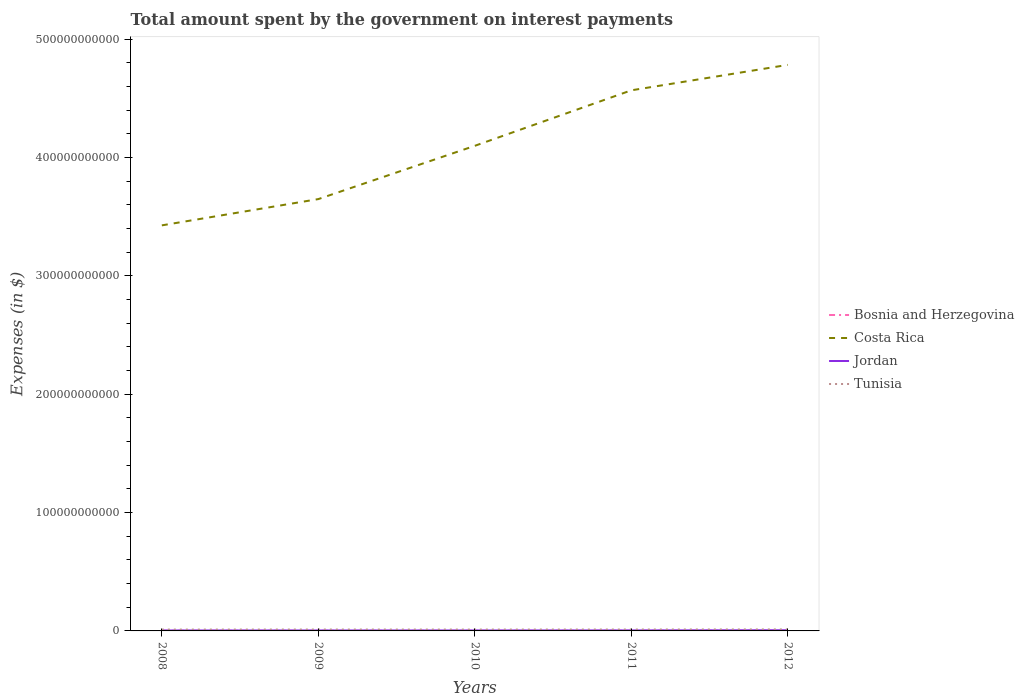How many different coloured lines are there?
Your answer should be very brief. 4. Across all years, what is the maximum amount spent on interest payments by the government in Jordan?
Your answer should be compact. 3.78e+08. What is the total amount spent on interest payments by the government in Jordan in the graph?
Keep it short and to the point. -5.17e+07. What is the difference between the highest and the second highest amount spent on interest payments by the government in Bosnia and Herzegovina?
Your answer should be compact. 7.29e+07. What is the difference between the highest and the lowest amount spent on interest payments by the government in Bosnia and Herzegovina?
Provide a short and direct response. 2. Is the amount spent on interest payments by the government in Jordan strictly greater than the amount spent on interest payments by the government in Tunisia over the years?
Your answer should be very brief. Yes. What is the difference between two consecutive major ticks on the Y-axis?
Keep it short and to the point. 1.00e+11. Where does the legend appear in the graph?
Provide a succinct answer. Center right. What is the title of the graph?
Your answer should be very brief. Total amount spent by the government on interest payments. Does "Kosovo" appear as one of the legend labels in the graph?
Provide a short and direct response. No. What is the label or title of the Y-axis?
Provide a succinct answer. Expenses (in $). What is the Expenses (in $) in Bosnia and Herzegovina in 2008?
Give a very brief answer. 1.15e+08. What is the Expenses (in $) in Costa Rica in 2008?
Ensure brevity in your answer.  3.43e+11. What is the Expenses (in $) in Jordan in 2008?
Offer a very short reply. 3.78e+08. What is the Expenses (in $) in Tunisia in 2008?
Offer a very short reply. 1.14e+09. What is the Expenses (in $) of Bosnia and Herzegovina in 2009?
Your answer should be compact. 1.13e+08. What is the Expenses (in $) in Costa Rica in 2009?
Offer a terse response. 3.65e+11. What is the Expenses (in $) of Jordan in 2009?
Offer a terse response. 3.92e+08. What is the Expenses (in $) of Tunisia in 2009?
Make the answer very short. 1.18e+09. What is the Expenses (in $) in Bosnia and Herzegovina in 2010?
Provide a succinct answer. 1.08e+08. What is the Expenses (in $) in Costa Rica in 2010?
Your answer should be compact. 4.10e+11. What is the Expenses (in $) of Jordan in 2010?
Your answer should be very brief. 3.98e+08. What is the Expenses (in $) of Tunisia in 2010?
Offer a very short reply. 1.15e+09. What is the Expenses (in $) of Bosnia and Herzegovina in 2011?
Make the answer very short. 1.44e+08. What is the Expenses (in $) in Costa Rica in 2011?
Make the answer very short. 4.57e+11. What is the Expenses (in $) of Jordan in 2011?
Provide a succinct answer. 4.30e+08. What is the Expenses (in $) of Tunisia in 2011?
Offer a very short reply. 1.19e+09. What is the Expenses (in $) of Bosnia and Herzegovina in 2012?
Offer a terse response. 1.81e+08. What is the Expenses (in $) of Costa Rica in 2012?
Give a very brief answer. 4.78e+11. What is the Expenses (in $) of Jordan in 2012?
Your answer should be compact. 5.83e+08. What is the Expenses (in $) in Tunisia in 2012?
Give a very brief answer. 1.27e+09. Across all years, what is the maximum Expenses (in $) of Bosnia and Herzegovina?
Your answer should be compact. 1.81e+08. Across all years, what is the maximum Expenses (in $) of Costa Rica?
Your answer should be very brief. 4.78e+11. Across all years, what is the maximum Expenses (in $) in Jordan?
Offer a very short reply. 5.83e+08. Across all years, what is the maximum Expenses (in $) of Tunisia?
Your answer should be compact. 1.27e+09. Across all years, what is the minimum Expenses (in $) of Bosnia and Herzegovina?
Make the answer very short. 1.08e+08. Across all years, what is the minimum Expenses (in $) of Costa Rica?
Keep it short and to the point. 3.43e+11. Across all years, what is the minimum Expenses (in $) of Jordan?
Keep it short and to the point. 3.78e+08. Across all years, what is the minimum Expenses (in $) in Tunisia?
Offer a very short reply. 1.14e+09. What is the total Expenses (in $) of Bosnia and Herzegovina in the graph?
Offer a very short reply. 6.60e+08. What is the total Expenses (in $) of Costa Rica in the graph?
Give a very brief answer. 2.05e+12. What is the total Expenses (in $) of Jordan in the graph?
Your response must be concise. 2.18e+09. What is the total Expenses (in $) of Tunisia in the graph?
Keep it short and to the point. 5.94e+09. What is the difference between the Expenses (in $) in Bosnia and Herzegovina in 2008 and that in 2009?
Give a very brief answer. 1.95e+06. What is the difference between the Expenses (in $) in Costa Rica in 2008 and that in 2009?
Give a very brief answer. -2.22e+1. What is the difference between the Expenses (in $) of Jordan in 2008 and that in 2009?
Your response must be concise. -1.44e+07. What is the difference between the Expenses (in $) of Tunisia in 2008 and that in 2009?
Offer a terse response. -3.76e+07. What is the difference between the Expenses (in $) of Bosnia and Herzegovina in 2008 and that in 2010?
Provide a short and direct response. 6.36e+06. What is the difference between the Expenses (in $) of Costa Rica in 2008 and that in 2010?
Your answer should be very brief. -6.72e+1. What is the difference between the Expenses (in $) in Jordan in 2008 and that in 2010?
Ensure brevity in your answer.  -1.97e+07. What is the difference between the Expenses (in $) of Tunisia in 2008 and that in 2010?
Your answer should be very brief. -9.50e+06. What is the difference between the Expenses (in $) in Bosnia and Herzegovina in 2008 and that in 2011?
Provide a succinct answer. -2.93e+07. What is the difference between the Expenses (in $) of Costa Rica in 2008 and that in 2011?
Make the answer very short. -1.14e+11. What is the difference between the Expenses (in $) of Jordan in 2008 and that in 2011?
Offer a very short reply. -5.17e+07. What is the difference between the Expenses (in $) of Tunisia in 2008 and that in 2011?
Keep it short and to the point. -4.76e+07. What is the difference between the Expenses (in $) in Bosnia and Herzegovina in 2008 and that in 2012?
Keep it short and to the point. -6.65e+07. What is the difference between the Expenses (in $) of Costa Rica in 2008 and that in 2012?
Offer a terse response. -1.36e+11. What is the difference between the Expenses (in $) of Jordan in 2008 and that in 2012?
Your answer should be compact. -2.05e+08. What is the difference between the Expenses (in $) of Tunisia in 2008 and that in 2012?
Give a very brief answer. -1.30e+08. What is the difference between the Expenses (in $) in Bosnia and Herzegovina in 2009 and that in 2010?
Provide a short and direct response. 4.41e+06. What is the difference between the Expenses (in $) of Costa Rica in 2009 and that in 2010?
Give a very brief answer. -4.50e+1. What is the difference between the Expenses (in $) in Jordan in 2009 and that in 2010?
Make the answer very short. -5.30e+06. What is the difference between the Expenses (in $) of Tunisia in 2009 and that in 2010?
Make the answer very short. 2.81e+07. What is the difference between the Expenses (in $) of Bosnia and Herzegovina in 2009 and that in 2011?
Offer a terse response. -3.12e+07. What is the difference between the Expenses (in $) in Costa Rica in 2009 and that in 2011?
Provide a succinct answer. -9.19e+1. What is the difference between the Expenses (in $) of Jordan in 2009 and that in 2011?
Give a very brief answer. -3.73e+07. What is the difference between the Expenses (in $) in Tunisia in 2009 and that in 2011?
Provide a succinct answer. -1.00e+07. What is the difference between the Expenses (in $) in Bosnia and Herzegovina in 2009 and that in 2012?
Give a very brief answer. -6.85e+07. What is the difference between the Expenses (in $) in Costa Rica in 2009 and that in 2012?
Offer a terse response. -1.13e+11. What is the difference between the Expenses (in $) in Jordan in 2009 and that in 2012?
Keep it short and to the point. -1.91e+08. What is the difference between the Expenses (in $) of Tunisia in 2009 and that in 2012?
Your answer should be compact. -9.20e+07. What is the difference between the Expenses (in $) of Bosnia and Herzegovina in 2010 and that in 2011?
Your answer should be compact. -3.56e+07. What is the difference between the Expenses (in $) in Costa Rica in 2010 and that in 2011?
Give a very brief answer. -4.69e+1. What is the difference between the Expenses (in $) of Jordan in 2010 and that in 2011?
Your response must be concise. -3.20e+07. What is the difference between the Expenses (in $) of Tunisia in 2010 and that in 2011?
Your answer should be very brief. -3.81e+07. What is the difference between the Expenses (in $) of Bosnia and Herzegovina in 2010 and that in 2012?
Provide a succinct answer. -7.29e+07. What is the difference between the Expenses (in $) of Costa Rica in 2010 and that in 2012?
Offer a terse response. -6.84e+1. What is the difference between the Expenses (in $) of Jordan in 2010 and that in 2012?
Offer a very short reply. -1.86e+08. What is the difference between the Expenses (in $) of Tunisia in 2010 and that in 2012?
Give a very brief answer. -1.20e+08. What is the difference between the Expenses (in $) in Bosnia and Herzegovina in 2011 and that in 2012?
Offer a terse response. -3.73e+07. What is the difference between the Expenses (in $) of Costa Rica in 2011 and that in 2012?
Make the answer very short. -2.15e+1. What is the difference between the Expenses (in $) of Jordan in 2011 and that in 2012?
Offer a very short reply. -1.54e+08. What is the difference between the Expenses (in $) in Tunisia in 2011 and that in 2012?
Offer a very short reply. -8.20e+07. What is the difference between the Expenses (in $) of Bosnia and Herzegovina in 2008 and the Expenses (in $) of Costa Rica in 2009?
Make the answer very short. -3.65e+11. What is the difference between the Expenses (in $) of Bosnia and Herzegovina in 2008 and the Expenses (in $) of Jordan in 2009?
Provide a succinct answer. -2.78e+08. What is the difference between the Expenses (in $) of Bosnia and Herzegovina in 2008 and the Expenses (in $) of Tunisia in 2009?
Provide a succinct answer. -1.07e+09. What is the difference between the Expenses (in $) of Costa Rica in 2008 and the Expenses (in $) of Jordan in 2009?
Provide a succinct answer. 3.42e+11. What is the difference between the Expenses (in $) of Costa Rica in 2008 and the Expenses (in $) of Tunisia in 2009?
Your answer should be compact. 3.41e+11. What is the difference between the Expenses (in $) in Jordan in 2008 and the Expenses (in $) in Tunisia in 2009?
Give a very brief answer. -8.02e+08. What is the difference between the Expenses (in $) of Bosnia and Herzegovina in 2008 and the Expenses (in $) of Costa Rica in 2010?
Your response must be concise. -4.10e+11. What is the difference between the Expenses (in $) of Bosnia and Herzegovina in 2008 and the Expenses (in $) of Jordan in 2010?
Offer a very short reply. -2.83e+08. What is the difference between the Expenses (in $) in Bosnia and Herzegovina in 2008 and the Expenses (in $) in Tunisia in 2010?
Offer a very short reply. -1.04e+09. What is the difference between the Expenses (in $) of Costa Rica in 2008 and the Expenses (in $) of Jordan in 2010?
Your answer should be very brief. 3.42e+11. What is the difference between the Expenses (in $) in Costa Rica in 2008 and the Expenses (in $) in Tunisia in 2010?
Provide a short and direct response. 3.41e+11. What is the difference between the Expenses (in $) in Jordan in 2008 and the Expenses (in $) in Tunisia in 2010?
Your answer should be very brief. -7.74e+08. What is the difference between the Expenses (in $) of Bosnia and Herzegovina in 2008 and the Expenses (in $) of Costa Rica in 2011?
Provide a succinct answer. -4.57e+11. What is the difference between the Expenses (in $) in Bosnia and Herzegovina in 2008 and the Expenses (in $) in Jordan in 2011?
Keep it short and to the point. -3.15e+08. What is the difference between the Expenses (in $) of Bosnia and Herzegovina in 2008 and the Expenses (in $) of Tunisia in 2011?
Offer a terse response. -1.08e+09. What is the difference between the Expenses (in $) of Costa Rica in 2008 and the Expenses (in $) of Jordan in 2011?
Offer a terse response. 3.42e+11. What is the difference between the Expenses (in $) in Costa Rica in 2008 and the Expenses (in $) in Tunisia in 2011?
Make the answer very short. 3.41e+11. What is the difference between the Expenses (in $) in Jordan in 2008 and the Expenses (in $) in Tunisia in 2011?
Make the answer very short. -8.12e+08. What is the difference between the Expenses (in $) in Bosnia and Herzegovina in 2008 and the Expenses (in $) in Costa Rica in 2012?
Make the answer very short. -4.78e+11. What is the difference between the Expenses (in $) in Bosnia and Herzegovina in 2008 and the Expenses (in $) in Jordan in 2012?
Ensure brevity in your answer.  -4.68e+08. What is the difference between the Expenses (in $) of Bosnia and Herzegovina in 2008 and the Expenses (in $) of Tunisia in 2012?
Your answer should be very brief. -1.16e+09. What is the difference between the Expenses (in $) of Costa Rica in 2008 and the Expenses (in $) of Jordan in 2012?
Your answer should be very brief. 3.42e+11. What is the difference between the Expenses (in $) of Costa Rica in 2008 and the Expenses (in $) of Tunisia in 2012?
Your answer should be very brief. 3.41e+11. What is the difference between the Expenses (in $) in Jordan in 2008 and the Expenses (in $) in Tunisia in 2012?
Make the answer very short. -8.94e+08. What is the difference between the Expenses (in $) in Bosnia and Herzegovina in 2009 and the Expenses (in $) in Costa Rica in 2010?
Provide a short and direct response. -4.10e+11. What is the difference between the Expenses (in $) in Bosnia and Herzegovina in 2009 and the Expenses (in $) in Jordan in 2010?
Your response must be concise. -2.85e+08. What is the difference between the Expenses (in $) of Bosnia and Herzegovina in 2009 and the Expenses (in $) of Tunisia in 2010?
Offer a terse response. -1.04e+09. What is the difference between the Expenses (in $) of Costa Rica in 2009 and the Expenses (in $) of Jordan in 2010?
Offer a terse response. 3.64e+11. What is the difference between the Expenses (in $) of Costa Rica in 2009 and the Expenses (in $) of Tunisia in 2010?
Your answer should be very brief. 3.64e+11. What is the difference between the Expenses (in $) of Jordan in 2009 and the Expenses (in $) of Tunisia in 2010?
Give a very brief answer. -7.60e+08. What is the difference between the Expenses (in $) of Bosnia and Herzegovina in 2009 and the Expenses (in $) of Costa Rica in 2011?
Offer a terse response. -4.57e+11. What is the difference between the Expenses (in $) of Bosnia and Herzegovina in 2009 and the Expenses (in $) of Jordan in 2011?
Make the answer very short. -3.17e+08. What is the difference between the Expenses (in $) in Bosnia and Herzegovina in 2009 and the Expenses (in $) in Tunisia in 2011?
Keep it short and to the point. -1.08e+09. What is the difference between the Expenses (in $) in Costa Rica in 2009 and the Expenses (in $) in Jordan in 2011?
Your response must be concise. 3.64e+11. What is the difference between the Expenses (in $) in Costa Rica in 2009 and the Expenses (in $) in Tunisia in 2011?
Your response must be concise. 3.64e+11. What is the difference between the Expenses (in $) in Jordan in 2009 and the Expenses (in $) in Tunisia in 2011?
Your response must be concise. -7.98e+08. What is the difference between the Expenses (in $) of Bosnia and Herzegovina in 2009 and the Expenses (in $) of Costa Rica in 2012?
Provide a succinct answer. -4.78e+11. What is the difference between the Expenses (in $) of Bosnia and Herzegovina in 2009 and the Expenses (in $) of Jordan in 2012?
Make the answer very short. -4.70e+08. What is the difference between the Expenses (in $) in Bosnia and Herzegovina in 2009 and the Expenses (in $) in Tunisia in 2012?
Your answer should be compact. -1.16e+09. What is the difference between the Expenses (in $) in Costa Rica in 2009 and the Expenses (in $) in Jordan in 2012?
Your answer should be compact. 3.64e+11. What is the difference between the Expenses (in $) of Costa Rica in 2009 and the Expenses (in $) of Tunisia in 2012?
Ensure brevity in your answer.  3.64e+11. What is the difference between the Expenses (in $) in Jordan in 2009 and the Expenses (in $) in Tunisia in 2012?
Give a very brief answer. -8.80e+08. What is the difference between the Expenses (in $) in Bosnia and Herzegovina in 2010 and the Expenses (in $) in Costa Rica in 2011?
Your answer should be very brief. -4.57e+11. What is the difference between the Expenses (in $) in Bosnia and Herzegovina in 2010 and the Expenses (in $) in Jordan in 2011?
Offer a terse response. -3.21e+08. What is the difference between the Expenses (in $) of Bosnia and Herzegovina in 2010 and the Expenses (in $) of Tunisia in 2011?
Keep it short and to the point. -1.08e+09. What is the difference between the Expenses (in $) of Costa Rica in 2010 and the Expenses (in $) of Jordan in 2011?
Keep it short and to the point. 4.09e+11. What is the difference between the Expenses (in $) of Costa Rica in 2010 and the Expenses (in $) of Tunisia in 2011?
Keep it short and to the point. 4.09e+11. What is the difference between the Expenses (in $) of Jordan in 2010 and the Expenses (in $) of Tunisia in 2011?
Your answer should be very brief. -7.93e+08. What is the difference between the Expenses (in $) of Bosnia and Herzegovina in 2010 and the Expenses (in $) of Costa Rica in 2012?
Your answer should be compact. -4.78e+11. What is the difference between the Expenses (in $) in Bosnia and Herzegovina in 2010 and the Expenses (in $) in Jordan in 2012?
Give a very brief answer. -4.75e+08. What is the difference between the Expenses (in $) of Bosnia and Herzegovina in 2010 and the Expenses (in $) of Tunisia in 2012?
Offer a terse response. -1.16e+09. What is the difference between the Expenses (in $) of Costa Rica in 2010 and the Expenses (in $) of Jordan in 2012?
Provide a succinct answer. 4.09e+11. What is the difference between the Expenses (in $) in Costa Rica in 2010 and the Expenses (in $) in Tunisia in 2012?
Ensure brevity in your answer.  4.09e+11. What is the difference between the Expenses (in $) of Jordan in 2010 and the Expenses (in $) of Tunisia in 2012?
Your response must be concise. -8.75e+08. What is the difference between the Expenses (in $) of Bosnia and Herzegovina in 2011 and the Expenses (in $) of Costa Rica in 2012?
Your answer should be very brief. -4.78e+11. What is the difference between the Expenses (in $) in Bosnia and Herzegovina in 2011 and the Expenses (in $) in Jordan in 2012?
Provide a short and direct response. -4.39e+08. What is the difference between the Expenses (in $) of Bosnia and Herzegovina in 2011 and the Expenses (in $) of Tunisia in 2012?
Offer a terse response. -1.13e+09. What is the difference between the Expenses (in $) of Costa Rica in 2011 and the Expenses (in $) of Jordan in 2012?
Offer a very short reply. 4.56e+11. What is the difference between the Expenses (in $) in Costa Rica in 2011 and the Expenses (in $) in Tunisia in 2012?
Offer a very short reply. 4.55e+11. What is the difference between the Expenses (in $) of Jordan in 2011 and the Expenses (in $) of Tunisia in 2012?
Your answer should be very brief. -8.43e+08. What is the average Expenses (in $) of Bosnia and Herzegovina per year?
Ensure brevity in your answer.  1.32e+08. What is the average Expenses (in $) of Costa Rica per year?
Your response must be concise. 4.10e+11. What is the average Expenses (in $) in Jordan per year?
Keep it short and to the point. 4.36e+08. What is the average Expenses (in $) of Tunisia per year?
Make the answer very short. 1.19e+09. In the year 2008, what is the difference between the Expenses (in $) in Bosnia and Herzegovina and Expenses (in $) in Costa Rica?
Ensure brevity in your answer.  -3.42e+11. In the year 2008, what is the difference between the Expenses (in $) in Bosnia and Herzegovina and Expenses (in $) in Jordan?
Your answer should be very brief. -2.63e+08. In the year 2008, what is the difference between the Expenses (in $) of Bosnia and Herzegovina and Expenses (in $) of Tunisia?
Provide a short and direct response. -1.03e+09. In the year 2008, what is the difference between the Expenses (in $) in Costa Rica and Expenses (in $) in Jordan?
Your answer should be very brief. 3.42e+11. In the year 2008, what is the difference between the Expenses (in $) in Costa Rica and Expenses (in $) in Tunisia?
Ensure brevity in your answer.  3.41e+11. In the year 2008, what is the difference between the Expenses (in $) in Jordan and Expenses (in $) in Tunisia?
Give a very brief answer. -7.65e+08. In the year 2009, what is the difference between the Expenses (in $) of Bosnia and Herzegovina and Expenses (in $) of Costa Rica?
Provide a short and direct response. -3.65e+11. In the year 2009, what is the difference between the Expenses (in $) in Bosnia and Herzegovina and Expenses (in $) in Jordan?
Your answer should be compact. -2.80e+08. In the year 2009, what is the difference between the Expenses (in $) in Bosnia and Herzegovina and Expenses (in $) in Tunisia?
Provide a succinct answer. -1.07e+09. In the year 2009, what is the difference between the Expenses (in $) of Costa Rica and Expenses (in $) of Jordan?
Keep it short and to the point. 3.64e+11. In the year 2009, what is the difference between the Expenses (in $) in Costa Rica and Expenses (in $) in Tunisia?
Ensure brevity in your answer.  3.64e+11. In the year 2009, what is the difference between the Expenses (in $) of Jordan and Expenses (in $) of Tunisia?
Your answer should be very brief. -7.88e+08. In the year 2010, what is the difference between the Expenses (in $) in Bosnia and Herzegovina and Expenses (in $) in Costa Rica?
Provide a succinct answer. -4.10e+11. In the year 2010, what is the difference between the Expenses (in $) of Bosnia and Herzegovina and Expenses (in $) of Jordan?
Make the answer very short. -2.89e+08. In the year 2010, what is the difference between the Expenses (in $) of Bosnia and Herzegovina and Expenses (in $) of Tunisia?
Your response must be concise. -1.04e+09. In the year 2010, what is the difference between the Expenses (in $) of Costa Rica and Expenses (in $) of Jordan?
Offer a terse response. 4.09e+11. In the year 2010, what is the difference between the Expenses (in $) in Costa Rica and Expenses (in $) in Tunisia?
Your answer should be compact. 4.09e+11. In the year 2010, what is the difference between the Expenses (in $) in Jordan and Expenses (in $) in Tunisia?
Your answer should be compact. -7.54e+08. In the year 2011, what is the difference between the Expenses (in $) of Bosnia and Herzegovina and Expenses (in $) of Costa Rica?
Your answer should be compact. -4.57e+11. In the year 2011, what is the difference between the Expenses (in $) in Bosnia and Herzegovina and Expenses (in $) in Jordan?
Ensure brevity in your answer.  -2.86e+08. In the year 2011, what is the difference between the Expenses (in $) of Bosnia and Herzegovina and Expenses (in $) of Tunisia?
Provide a short and direct response. -1.05e+09. In the year 2011, what is the difference between the Expenses (in $) of Costa Rica and Expenses (in $) of Jordan?
Provide a succinct answer. 4.56e+11. In the year 2011, what is the difference between the Expenses (in $) in Costa Rica and Expenses (in $) in Tunisia?
Provide a short and direct response. 4.55e+11. In the year 2011, what is the difference between the Expenses (in $) of Jordan and Expenses (in $) of Tunisia?
Provide a short and direct response. -7.61e+08. In the year 2012, what is the difference between the Expenses (in $) of Bosnia and Herzegovina and Expenses (in $) of Costa Rica?
Ensure brevity in your answer.  -4.78e+11. In the year 2012, what is the difference between the Expenses (in $) of Bosnia and Herzegovina and Expenses (in $) of Jordan?
Ensure brevity in your answer.  -4.02e+08. In the year 2012, what is the difference between the Expenses (in $) in Bosnia and Herzegovina and Expenses (in $) in Tunisia?
Your response must be concise. -1.09e+09. In the year 2012, what is the difference between the Expenses (in $) in Costa Rica and Expenses (in $) in Jordan?
Make the answer very short. 4.78e+11. In the year 2012, what is the difference between the Expenses (in $) in Costa Rica and Expenses (in $) in Tunisia?
Your answer should be very brief. 4.77e+11. In the year 2012, what is the difference between the Expenses (in $) of Jordan and Expenses (in $) of Tunisia?
Your response must be concise. -6.89e+08. What is the ratio of the Expenses (in $) in Bosnia and Herzegovina in 2008 to that in 2009?
Keep it short and to the point. 1.02. What is the ratio of the Expenses (in $) in Costa Rica in 2008 to that in 2009?
Your response must be concise. 0.94. What is the ratio of the Expenses (in $) of Jordan in 2008 to that in 2009?
Provide a succinct answer. 0.96. What is the ratio of the Expenses (in $) in Tunisia in 2008 to that in 2009?
Your response must be concise. 0.97. What is the ratio of the Expenses (in $) of Bosnia and Herzegovina in 2008 to that in 2010?
Keep it short and to the point. 1.06. What is the ratio of the Expenses (in $) of Costa Rica in 2008 to that in 2010?
Provide a succinct answer. 0.84. What is the ratio of the Expenses (in $) in Jordan in 2008 to that in 2010?
Offer a terse response. 0.95. What is the ratio of the Expenses (in $) in Bosnia and Herzegovina in 2008 to that in 2011?
Make the answer very short. 0.8. What is the ratio of the Expenses (in $) of Costa Rica in 2008 to that in 2011?
Provide a succinct answer. 0.75. What is the ratio of the Expenses (in $) of Jordan in 2008 to that in 2011?
Ensure brevity in your answer.  0.88. What is the ratio of the Expenses (in $) of Tunisia in 2008 to that in 2011?
Offer a terse response. 0.96. What is the ratio of the Expenses (in $) in Bosnia and Herzegovina in 2008 to that in 2012?
Your answer should be compact. 0.63. What is the ratio of the Expenses (in $) in Costa Rica in 2008 to that in 2012?
Your response must be concise. 0.72. What is the ratio of the Expenses (in $) in Jordan in 2008 to that in 2012?
Provide a short and direct response. 0.65. What is the ratio of the Expenses (in $) of Tunisia in 2008 to that in 2012?
Offer a terse response. 0.9. What is the ratio of the Expenses (in $) in Bosnia and Herzegovina in 2009 to that in 2010?
Offer a terse response. 1.04. What is the ratio of the Expenses (in $) of Costa Rica in 2009 to that in 2010?
Offer a terse response. 0.89. What is the ratio of the Expenses (in $) of Jordan in 2009 to that in 2010?
Your response must be concise. 0.99. What is the ratio of the Expenses (in $) of Tunisia in 2009 to that in 2010?
Provide a short and direct response. 1.02. What is the ratio of the Expenses (in $) in Bosnia and Herzegovina in 2009 to that in 2011?
Provide a short and direct response. 0.78. What is the ratio of the Expenses (in $) in Costa Rica in 2009 to that in 2011?
Your answer should be very brief. 0.8. What is the ratio of the Expenses (in $) in Jordan in 2009 to that in 2011?
Provide a succinct answer. 0.91. What is the ratio of the Expenses (in $) in Tunisia in 2009 to that in 2011?
Keep it short and to the point. 0.99. What is the ratio of the Expenses (in $) in Bosnia and Herzegovina in 2009 to that in 2012?
Your answer should be compact. 0.62. What is the ratio of the Expenses (in $) of Costa Rica in 2009 to that in 2012?
Keep it short and to the point. 0.76. What is the ratio of the Expenses (in $) of Jordan in 2009 to that in 2012?
Ensure brevity in your answer.  0.67. What is the ratio of the Expenses (in $) in Tunisia in 2009 to that in 2012?
Offer a very short reply. 0.93. What is the ratio of the Expenses (in $) of Bosnia and Herzegovina in 2010 to that in 2011?
Your answer should be compact. 0.75. What is the ratio of the Expenses (in $) of Costa Rica in 2010 to that in 2011?
Provide a succinct answer. 0.9. What is the ratio of the Expenses (in $) of Jordan in 2010 to that in 2011?
Give a very brief answer. 0.93. What is the ratio of the Expenses (in $) of Bosnia and Herzegovina in 2010 to that in 2012?
Ensure brevity in your answer.  0.6. What is the ratio of the Expenses (in $) in Costa Rica in 2010 to that in 2012?
Offer a terse response. 0.86. What is the ratio of the Expenses (in $) of Jordan in 2010 to that in 2012?
Your response must be concise. 0.68. What is the ratio of the Expenses (in $) of Tunisia in 2010 to that in 2012?
Your response must be concise. 0.91. What is the ratio of the Expenses (in $) of Bosnia and Herzegovina in 2011 to that in 2012?
Give a very brief answer. 0.79. What is the ratio of the Expenses (in $) of Costa Rica in 2011 to that in 2012?
Ensure brevity in your answer.  0.95. What is the ratio of the Expenses (in $) of Jordan in 2011 to that in 2012?
Provide a short and direct response. 0.74. What is the ratio of the Expenses (in $) of Tunisia in 2011 to that in 2012?
Your response must be concise. 0.94. What is the difference between the highest and the second highest Expenses (in $) of Bosnia and Herzegovina?
Ensure brevity in your answer.  3.73e+07. What is the difference between the highest and the second highest Expenses (in $) of Costa Rica?
Your answer should be very brief. 2.15e+1. What is the difference between the highest and the second highest Expenses (in $) in Jordan?
Your answer should be compact. 1.54e+08. What is the difference between the highest and the second highest Expenses (in $) in Tunisia?
Ensure brevity in your answer.  8.20e+07. What is the difference between the highest and the lowest Expenses (in $) of Bosnia and Herzegovina?
Your answer should be compact. 7.29e+07. What is the difference between the highest and the lowest Expenses (in $) in Costa Rica?
Provide a short and direct response. 1.36e+11. What is the difference between the highest and the lowest Expenses (in $) in Jordan?
Your answer should be compact. 2.05e+08. What is the difference between the highest and the lowest Expenses (in $) in Tunisia?
Offer a terse response. 1.30e+08. 